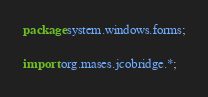Convert code to text. <code><loc_0><loc_0><loc_500><loc_500><_Java_>
package system.windows.forms;

import org.mases.jcobridge.*;</code> 